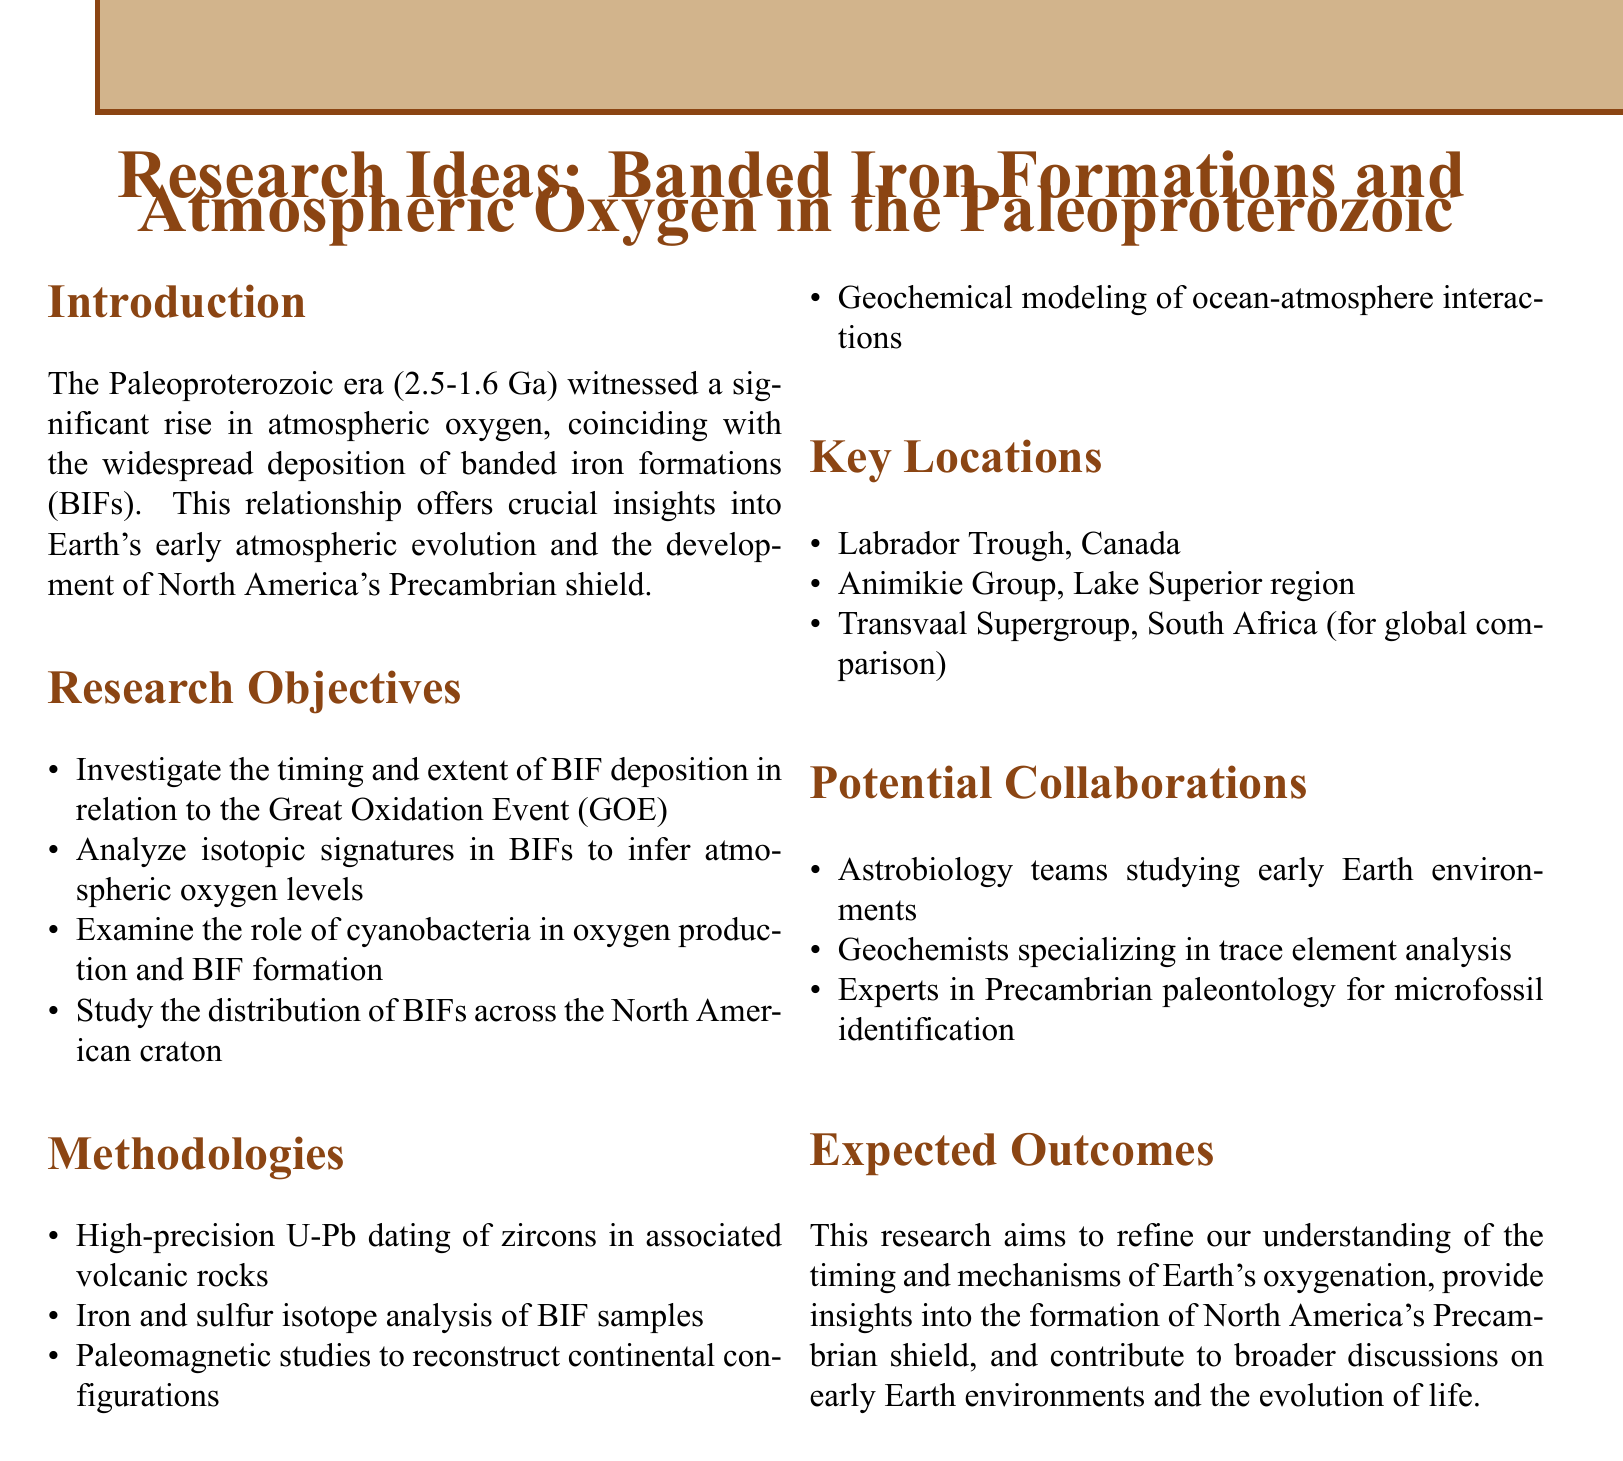What is the time range of the Paleoproterozoic era? The document states that the Paleoproterozoic era spans from 2.5 to 1.6 billion years ago (Ga).
Answer: 2.5-1.6 Ga What relationship is highlighted in the introduction? The introduction discusses the significant rise in atmospheric oxygen and its coincidence with the deposition of banded iron formations (BIFs).
Answer: Banded iron formations What is one of the key methods proposed for analysis? The document lists high-precision U-Pb dating of zircons in associated volcanic rocks as a methodology for analysis.
Answer: U-Pb dating Which location in Canada is mentioned as a key site? The Labrador Trough is identified as a significant research location within Canada.
Answer: Labrador Trough What is the main objective of the research? The primary aim of the research is to refine the understanding of the timing and mechanisms of Earth's oxygenation.
Answer: Earth's oxygenation What type of collaborations are suggested in the document? The document suggests collaborations with astrobiology teams studying early Earth environments.
Answer: Astrobiology teams What is one research objective related to cyanobacteria? One of the research objectives is to examine the role of cyanobacteria in oxygen production and BIF formation.
Answer: Cyanobacteria How many key locations are listed in the document? The document lists three key locations for the research focus.
Answer: Three 